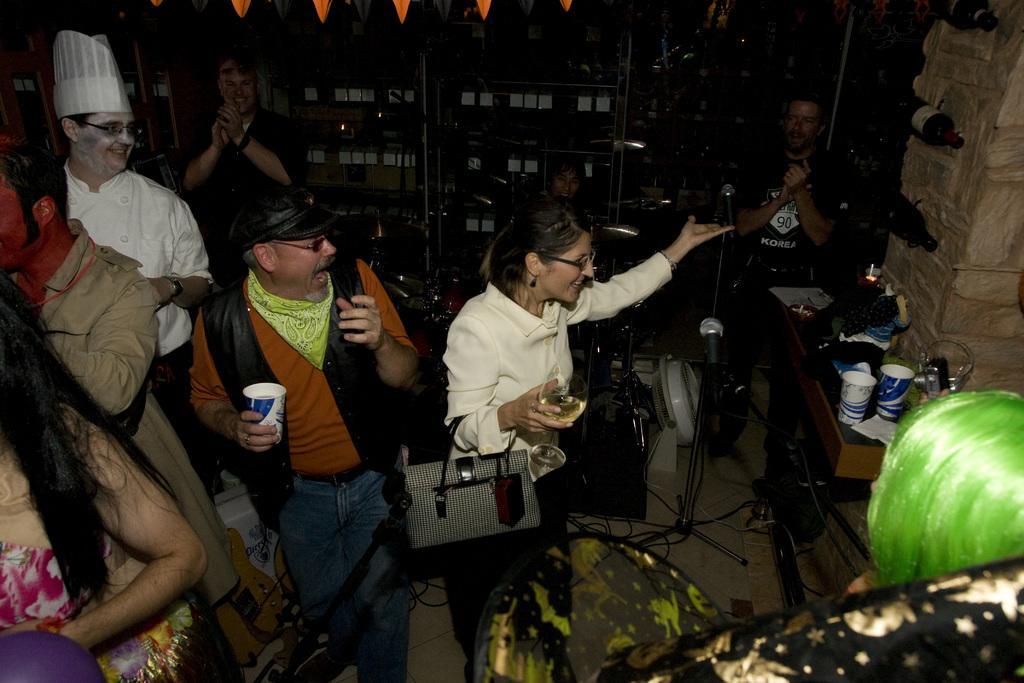Can you describe this image briefly? Background portion of the picture is dark. In this picture we can see the people. We can see a man and a woman are holding glasses. On the right side of the picture we can see a platform. On a platform we can see glasses and few objects. In this picture we can see microphones, stands, pillar, bottles and objects. 